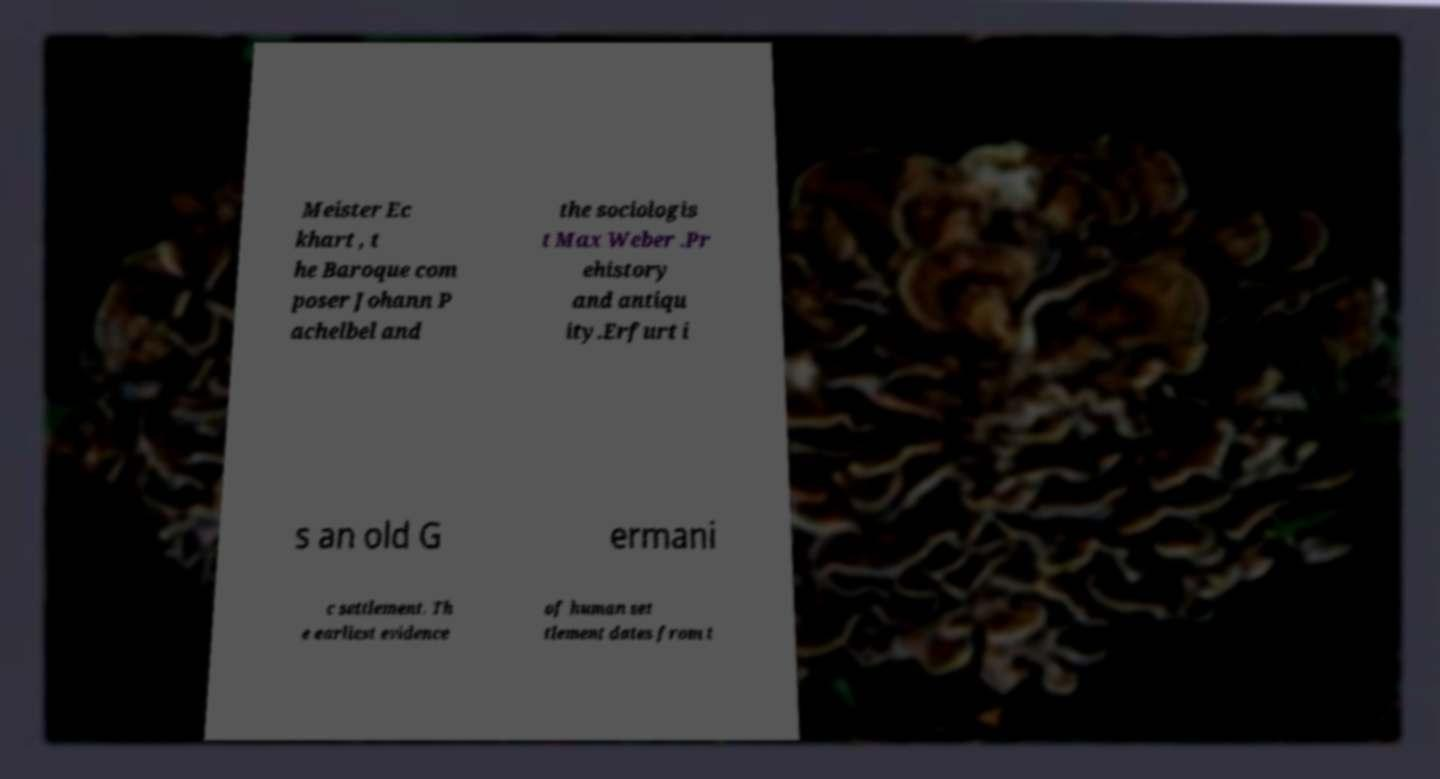There's text embedded in this image that I need extracted. Can you transcribe it verbatim? Meister Ec khart , t he Baroque com poser Johann P achelbel and the sociologis t Max Weber .Pr ehistory and antiqu ity.Erfurt i s an old G ermani c settlement. Th e earliest evidence of human set tlement dates from t 